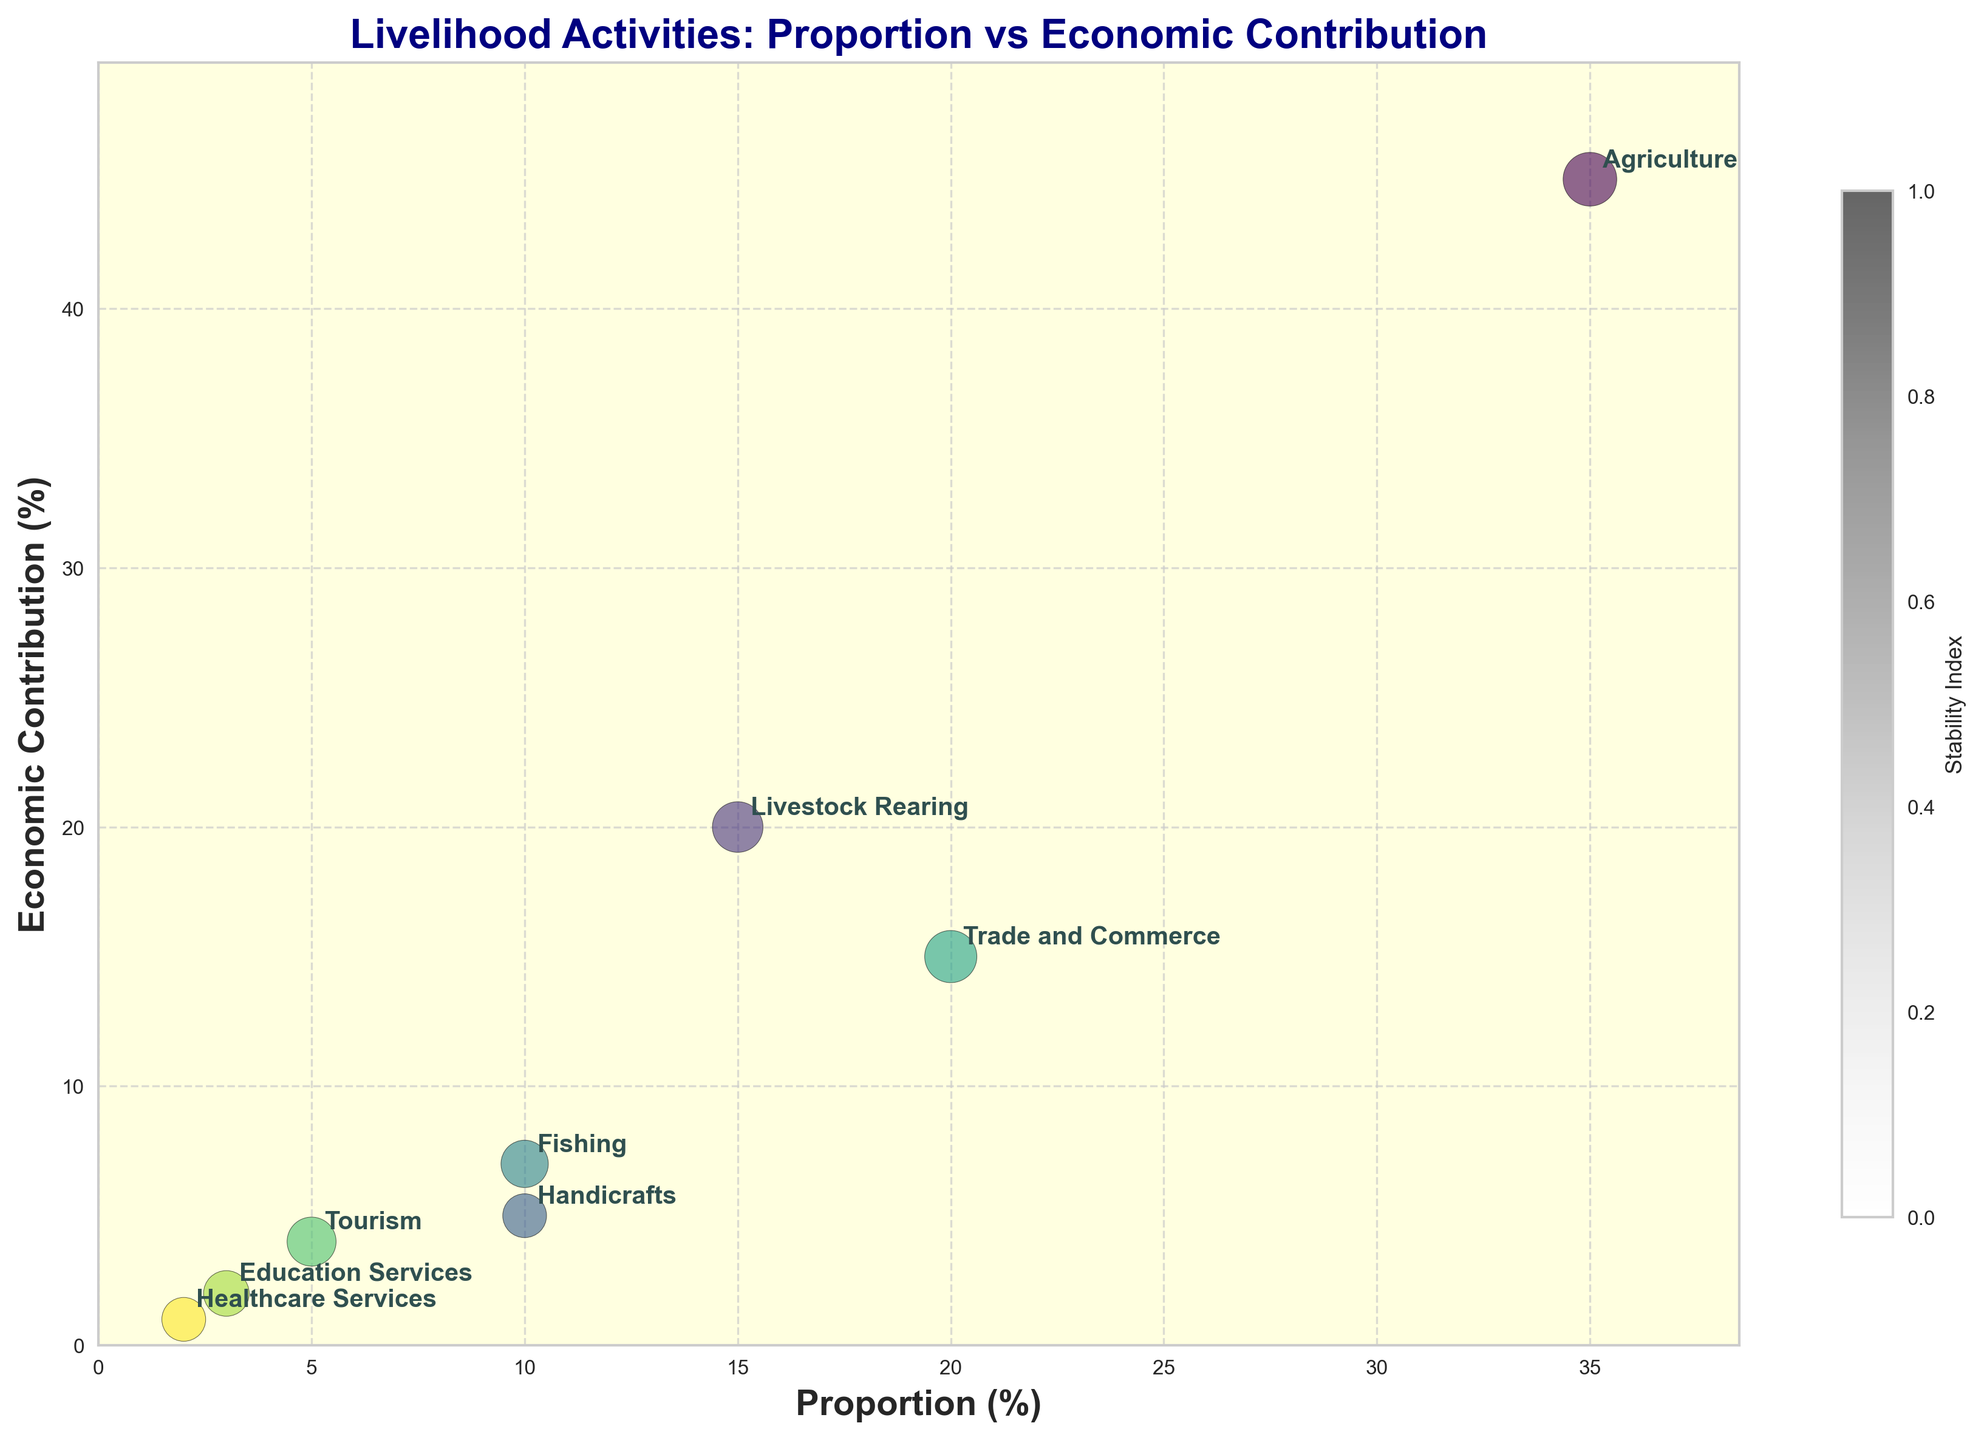What is the title of the figure? The title is usually displayed at the top of the figure. It provides a brief description of what the figure represents. Here, the title is "Livelihood Activities: Proportion vs Economic Contribution".
Answer: Livelihood Activities: Proportion vs Economic Contribution What do the x-axis and y-axis represent? The x-axis label is located along the horizontal axis, and it represents 'Proportion (%)', whereas the y-axis label is located along the vertical axis, and it stands for 'Economic Contribution (%)'.
Answer: Proportion (%) and Economic Contribution (%) Which livelihood activity contributes the most to economic stability? To find this, look at the bubbles with the largest area since the size of the bubbles represents the 'Stability Index'. 'Agriculture' has the largest bubble.
Answer: Agriculture How many different livelihood activities are depicted in the figure? Each bubble in the figure represents a different livelihood activity. By counting the number of bubbles, we get the total number of activities.
Answer: 8 Which activity has a proportion of 20% and an economic contribution of 15%? By examining the plot, find the bubble at (20%, 15%). The annotated label shows that this bubble represents 'Trade and Commerce'.
Answer: Trade and Commerce Compare the stability index between 'Handicrafts' and 'Tourism'. Which is more stable? 'Handicrafts' has a stability index of 0.6 and 'Tourism' has a stability index of 0.75. Since a higher value indicates greater stability, 'Tourism' is more stable.
Answer: Tourism What is the combined proportion (%) of 'Fishing' and 'Livestock Rearing'? Adding the proportions of 'Fishing' (10%) and 'Livestock Rearing' (15%), the combined proportion is 10% + 15% = 25%.
Answer: 25% Which activity has the lowest economic contribution and what is it? The smallest value on the y-axis represents the lowest economic contribution. 'Healthcare Services' has the lowest economic contribution with 1%.
Answer: Healthcare Services, 1% Identify any two activities that have both a proportion less than 10% and an economic contribution less than 10%. Bubbles lying below both 10% on the x-axis and y-axis represent the required activities. These are 'Healthcare Services' and 'Education Services'.
Answer: Healthcare Services and Education Services Which activity has a stability index of 0.85? Examining the size of the bubbles, the activity with a stability index of 0.85 is indicated by the size assigned. It’s annotated as "Trade and Commerce".
Answer: Trade and Commerce 